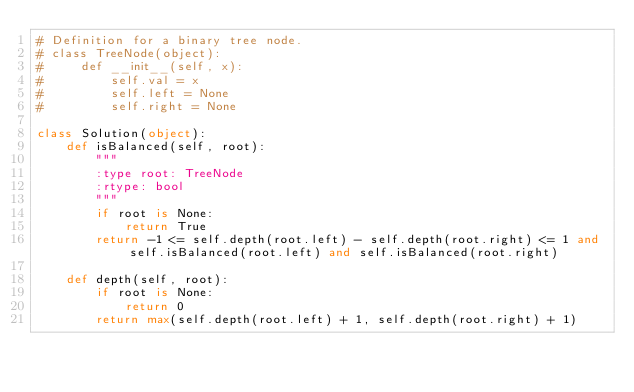<code> <loc_0><loc_0><loc_500><loc_500><_Python_># Definition for a binary tree node.
# class TreeNode(object):
#     def __init__(self, x):
#         self.val = x
#         self.left = None
#         self.right = None

class Solution(object):
    def isBalanced(self, root):
        """
        :type root: TreeNode
        :rtype: bool
        """
        if root is None:
            return True
        return -1 <= self.depth(root.left) - self.depth(root.right) <= 1 and self.isBalanced(root.left) and self.isBalanced(root.right)

    def depth(self, root):
        if root is None:
            return 0
        return max(self.depth(root.left) + 1, self.depth(root.right) + 1)
</code> 